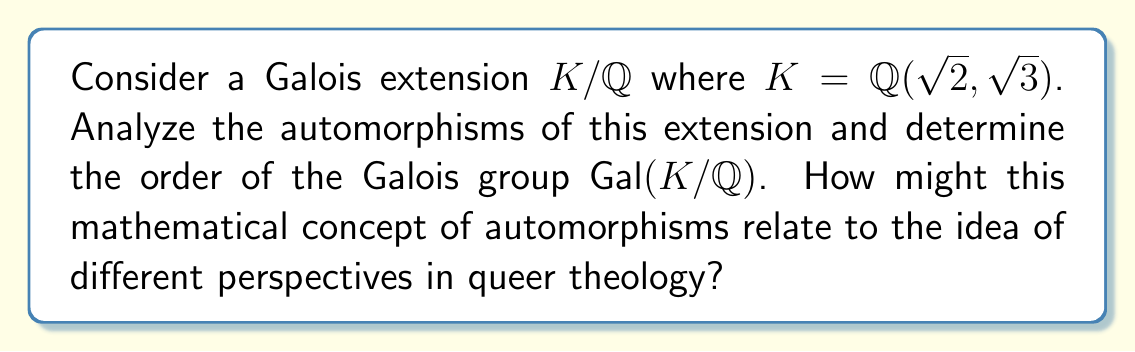Show me your answer to this math problem. 1) First, we need to understand the structure of $K = \mathbb{Q}(\sqrt{2}, \sqrt{3})$:
   - This is a biquadratic extension of $\mathbb{Q}$.
   - $[K:\mathbb{Q}] = 4$ as it's generated by two independent square roots.

2) The automorphisms of $K/\mathbb{Q}$ are determined by their action on $\sqrt{2}$ and $\sqrt{3}$:
   - $\sigma_1: \sqrt{2} \mapsto \sqrt{2}, \sqrt{3} \mapsto \sqrt{3}$ (identity)
   - $\sigma_2: \sqrt{2} \mapsto -\sqrt{2}, \sqrt{3} \mapsto \sqrt{3}$
   - $\sigma_3: \sqrt{2} \mapsto \sqrt{2}, \sqrt{3} \mapsto -\sqrt{3}$
   - $\sigma_4: \sqrt{2} \mapsto -\sqrt{2}, \sqrt{3} \mapsto -\sqrt{3}$

3) These four automorphisms form the Galois group $\text{Gal}(K/\mathbb{Q})$.

4) The order of $\text{Gal}(K/\mathbb{Q})$ is 4, which matches $[K:\mathbb{Q}]$ as expected for a Galois extension.

5) Relating to queer theology:
   - Each automorphism represents a different "perspective" on the elements of $K$.
   - Just as queer theology offers new perspectives on traditional religious texts and concepts, automorphisms provide different ways of viewing the same mathematical structure.
   - The interplay between these perspectives (automorphisms) forms the complete picture (Galois group), similar to how diverse perspectives in queer theology contribute to a fuller understanding of faith and identity.
Answer: $|\text{Gal}(K/\mathbb{Q})| = 4$ 